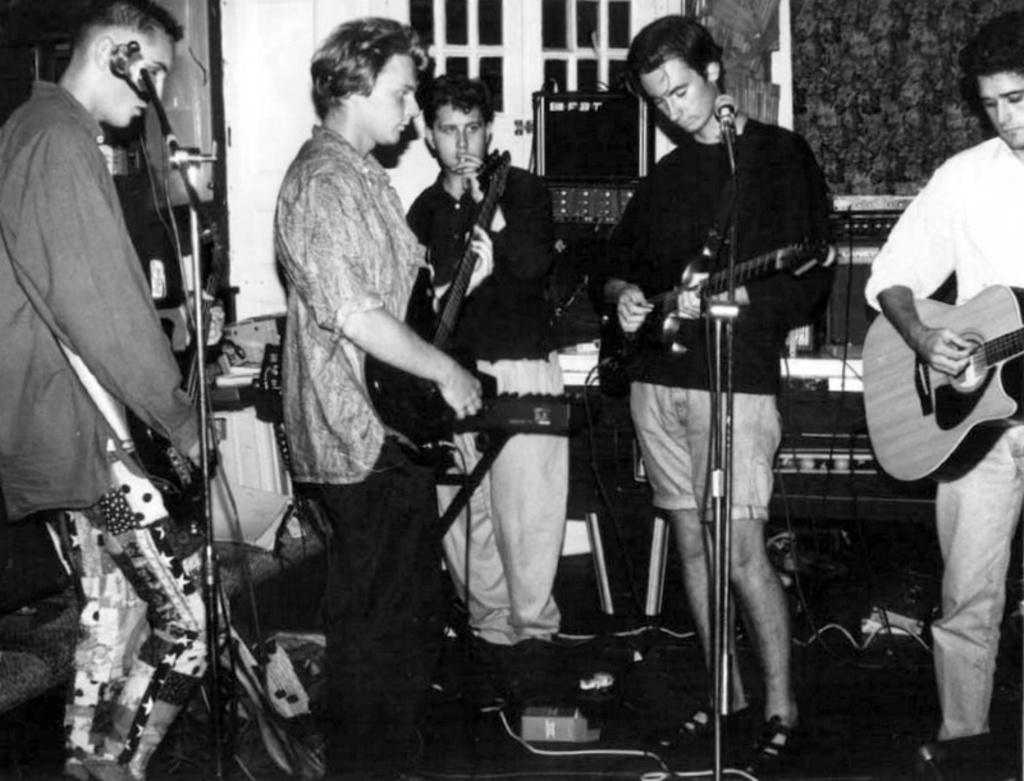What is the color scheme of the image? The image is black and white. What can be seen in the background of the image? There are windows and a door in the background. What are the men in the image doing? The men are standing in front of a microphone and playing guitars. What is the surface beneath the men in the image? The image shows a floor. How many kittens are playing on the range in the image? There are no kittens or ranges present in the image. What type of face can be seen on the men in the image? The image is black and white, so it is not possible to determine the facial features of the men. 